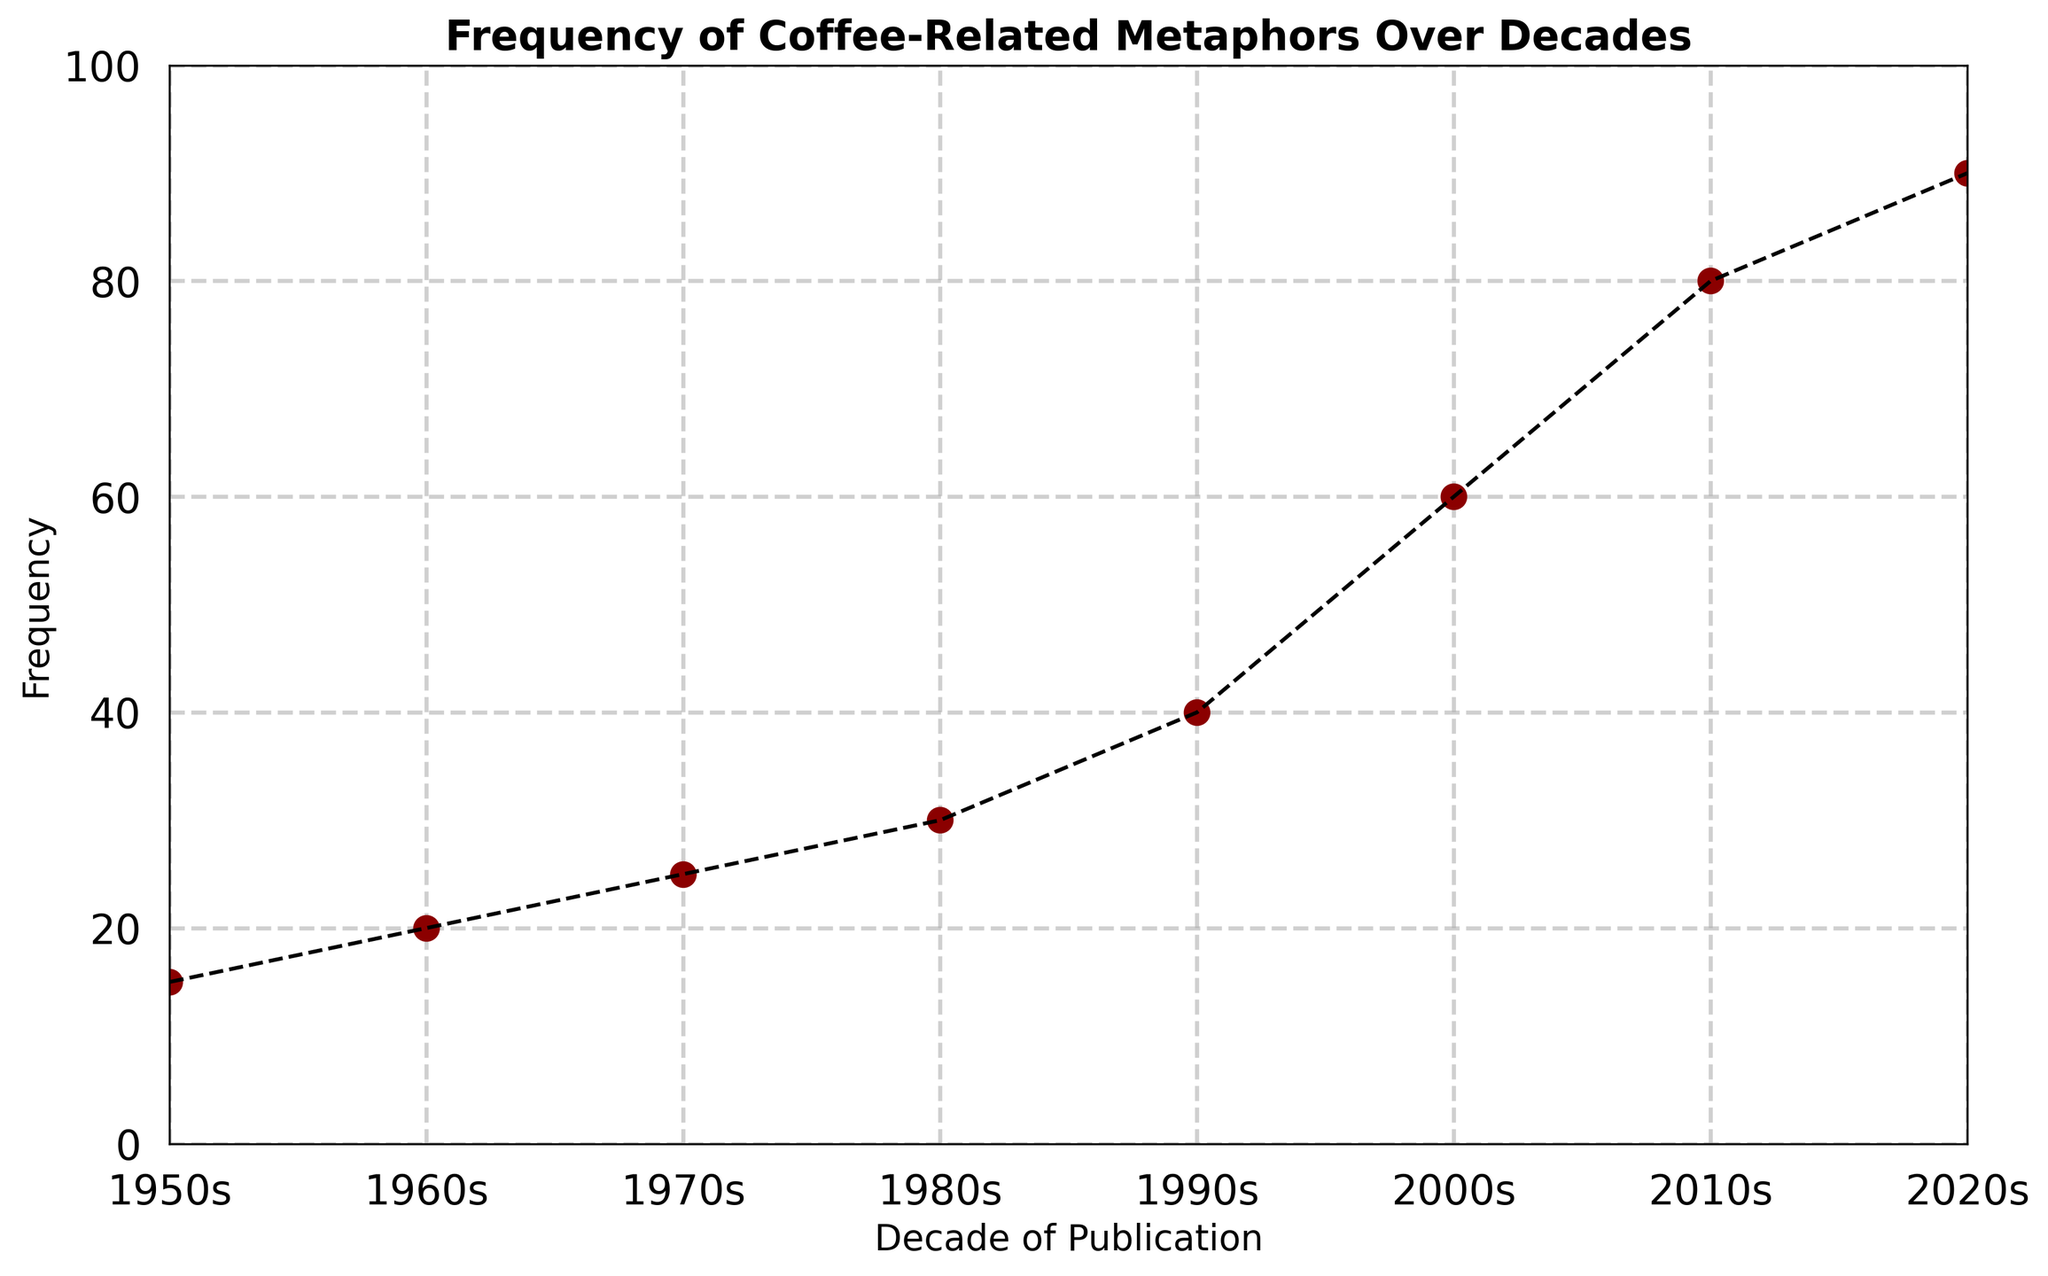What is the frequency of coffee-related metaphors in the 1980s? We need to look at the point corresponding to the 1980s on the x-axis. The y-axis value is the frequency. For the 1980s, this frequency is 30.
Answer: 30 Has the frequency of coffee-related metaphors generally increased or decreased over time? By observing the trend of the points from left to right, we see an upward trajectory, indicating an increase in frequency over time.
Answer: Increased Between which two consecutive decades did the frequency of coffee-related metaphors see the largest increase? We need to calculate the frequency differences between each consecutive decade and identify the largest one. The differences are: 1960s-1950s (5), 1970s-1960s (5), 1980s-1970s (5), 1990s-1980s (10), 2000s-1990s (20), 2010s-2000s (20), 2020s-2010s (10). The largest increase is 2000s to 2010s and 2010s to 2020s both by 20.
Answer: 2000s to 2010s What was the average frequency of coffee-related metaphors in the decades from the 1950s to the 1980s? Add the frequencies of the 1950s, 1960s, 1970s, and 1980s, then divide by the number of decades. (15 + 20 + 25 + 30)/4 = 22.5
Answer: 22.5 Which decade had a frequency of coffee-related metaphors closest to 50? By inspecting the points, we see that the 1990s had a frequency of 40 and the 2000s had a frequency of 60. The 2000s are closer to 50.
Answer: 2000s How does the frequency of coffee-related metaphors in the 2020s compare to the 2000s? Look at the plotted points for the 2020s (90) and the 2000s (60). The frequency in the 2020s is higher by 30.
Answer: Higher What's the total increase in frequency from the 1950s to the 2020s? Subtract the frequency in the 1950s from the frequency in the 2020s. 90 - 15 = 75
Answer: 75 What is the difference in frequency between the 1970s and the 1990s? Subtract the frequency in the 1970s from the frequency in the 1990s. 40 - 25 = 15
Answer: 15 